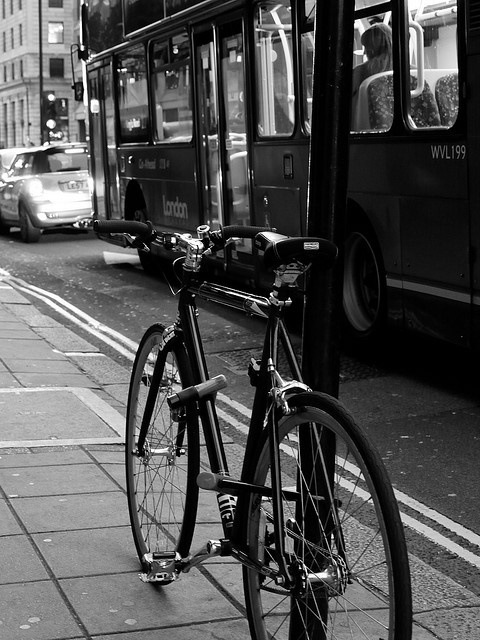Describe the objects in this image and their specific colors. I can see bus in lightgray, black, gray, and darkgray tones, bicycle in lightgray, black, gray, and darkgray tones, car in lightgray, white, darkgray, black, and gray tones, people in lightgray, black, gray, and darkgray tones, and traffic light in lightgray, black, gray, white, and darkgray tones in this image. 